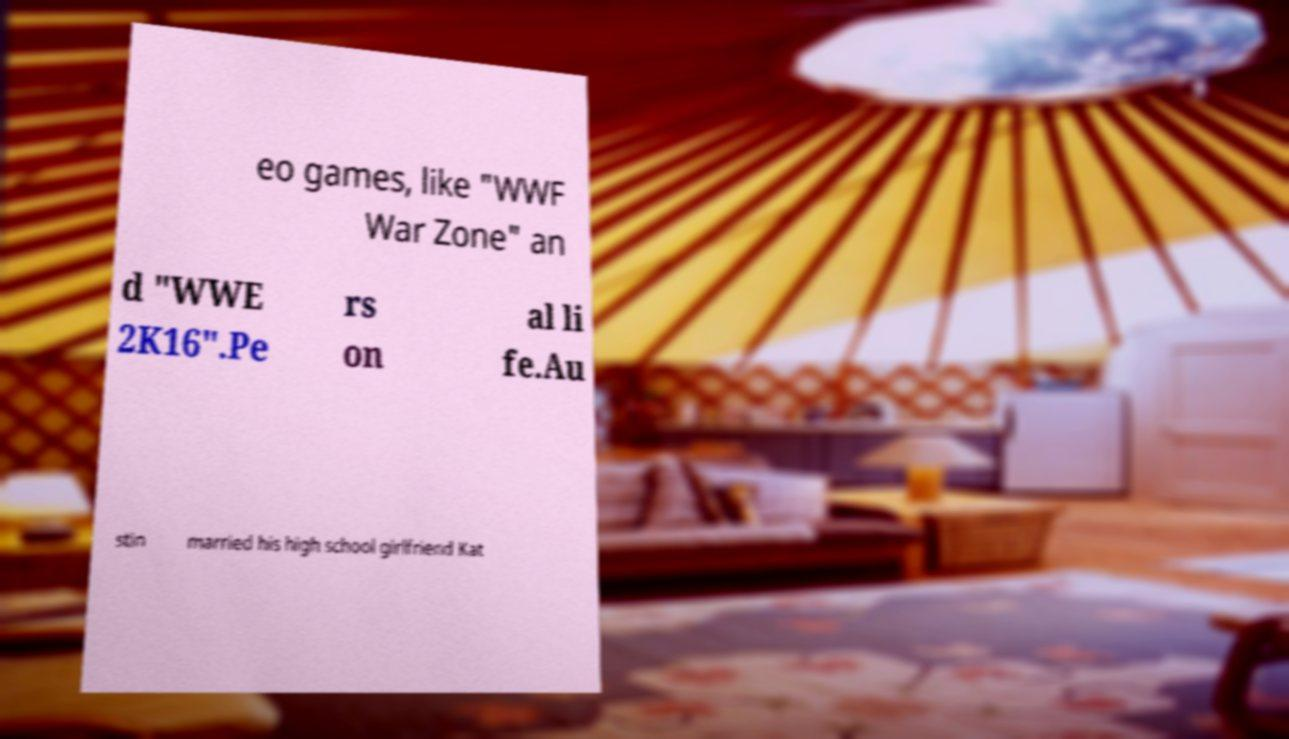Please read and relay the text visible in this image. What does it say? eo games, like "WWF War Zone" an d "WWE 2K16".Pe rs on al li fe.Au stin married his high school girlfriend Kat 